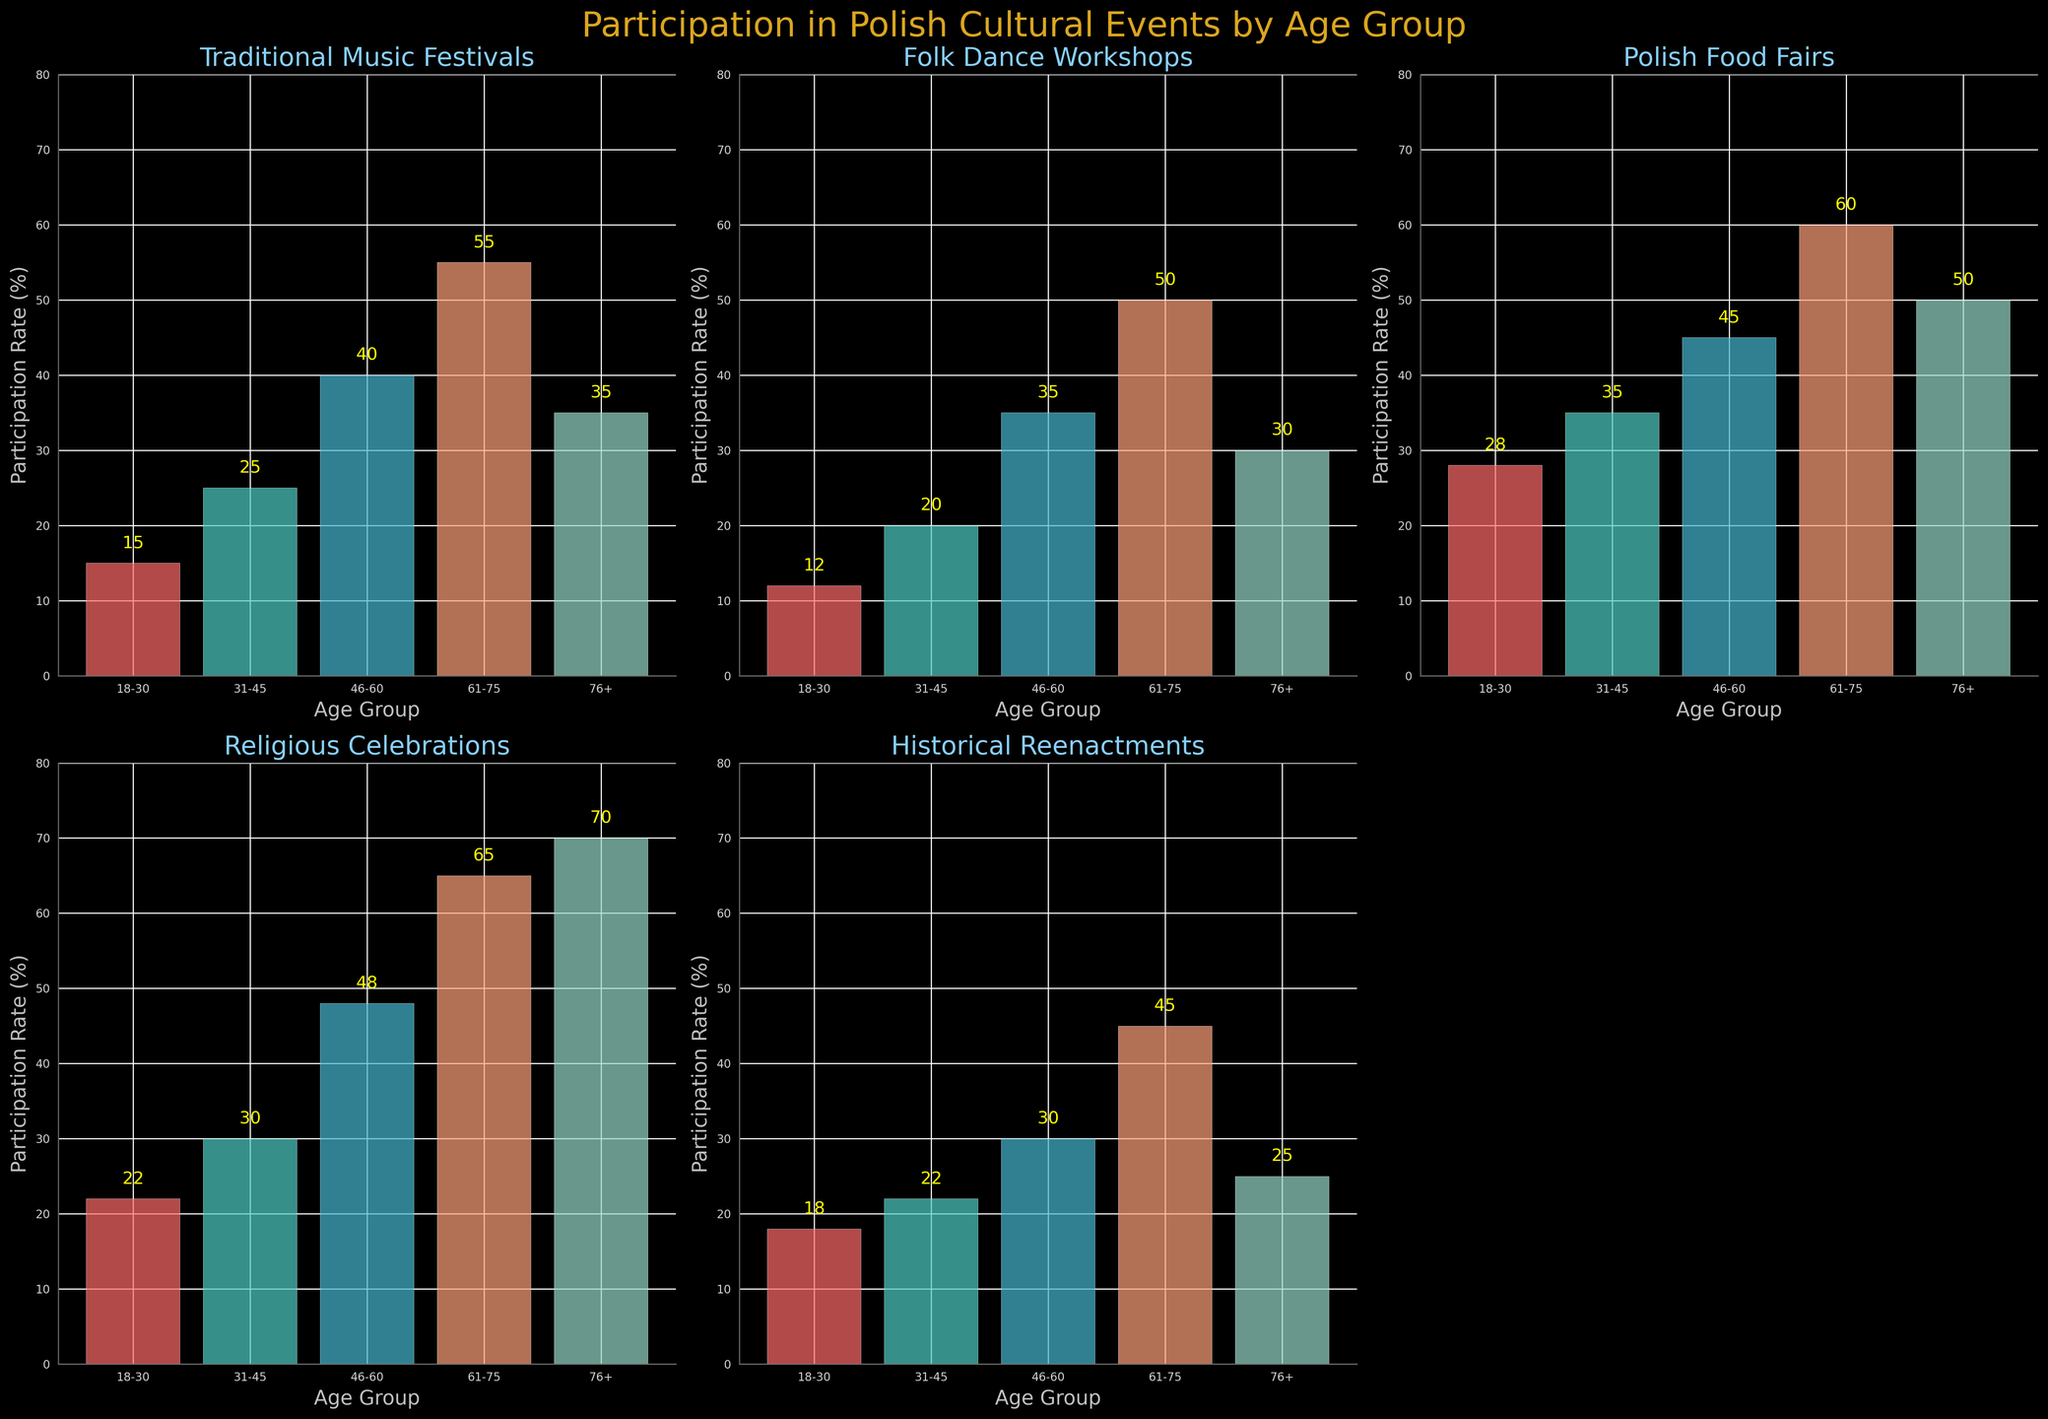What's the title of the figure? The title is located at the top center of the figure in large, goldenrod-colored text.
Answer: Participation in Polish Cultural Events by Age Group Which age group has the highest participation rate in Polish Food Fairs? The Polish Food Fairs plot shows the highest bar for the age group 61-75, and the text above the bar indicates a value of 60.
Answer: 61-75 How many event types are shown in the figure? The figure consists of subplots for each event type, and counting the subplot titles gives five event types.
Answer: Five What is the participation rate for the age group 76+ in Traditional Music Festivals? By checking the Traditional Music Festivals subplot, the bar for age group 76+ displays a value of 35.
Answer: 35 Which event type has the smallest participation rate for age group 18-30? In each subplot, find the bar corresponding to age group 18-30 and compare the heights. The lowest value among them is in Folk Dance Workshops, showing a rate of 12.
Answer: Folk Dance Workshops Which age group has the greatest range of participation rates across all event types? Calculate the range for each age group: 76+ (70-25=45), 61-75 (65-45=20), 46-60 (48-30=18), 31-45 (35-20=15), and 18-30 (28-12=16). The age group 76+ has the highest range.
Answer: 76+ Between which two age groups is there the biggest difference in participation rates for Historical Reenactments? In the Historical Reenactments subplot, the greatest difference occurs between age groups 61-75 (45) and 76+ (25). The difference is 45 - 25 = 20.
Answer: 61-75 and 76+ On which event type does the age group 61-75 have the highest participation rate compared to the other age groups? Comparing the values within the 61-75 bars across all subplots, the highest value is 70 for Religious Celebrations.
Answer: Religious Celebrations What is the average participation rate of the age group 46-60 across all event types? Sum the participation rates for 46-60 (40 + 35 + 45 + 48 + 30 = 198) and divide by 5 (198/5 = 39.6).
Answer: 39.6 Which age group shows a participation rate higher than 45% in any two events but not in the others? The age group 46-60 has rates of 45% (Polish Food Fairs) and 48% (Religious Celebrations) but all lower in other events.
Answer: 46-60 